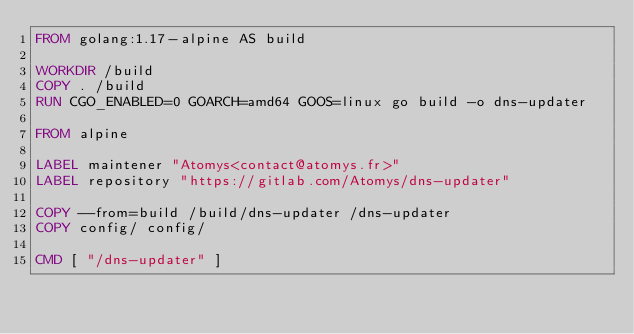Convert code to text. <code><loc_0><loc_0><loc_500><loc_500><_Dockerfile_>FROM golang:1.17-alpine AS build

WORKDIR /build
COPY . /build
RUN CGO_ENABLED=0 GOARCH=amd64 GOOS=linux go build -o dns-updater

FROM alpine

LABEL maintener "Atomys<contact@atomys.fr>"
LABEL repository "https://gitlab.com/Atomys/dns-updater"

COPY --from=build /build/dns-updater /dns-updater
COPY config/ config/

CMD [ "/dns-updater" ]</code> 